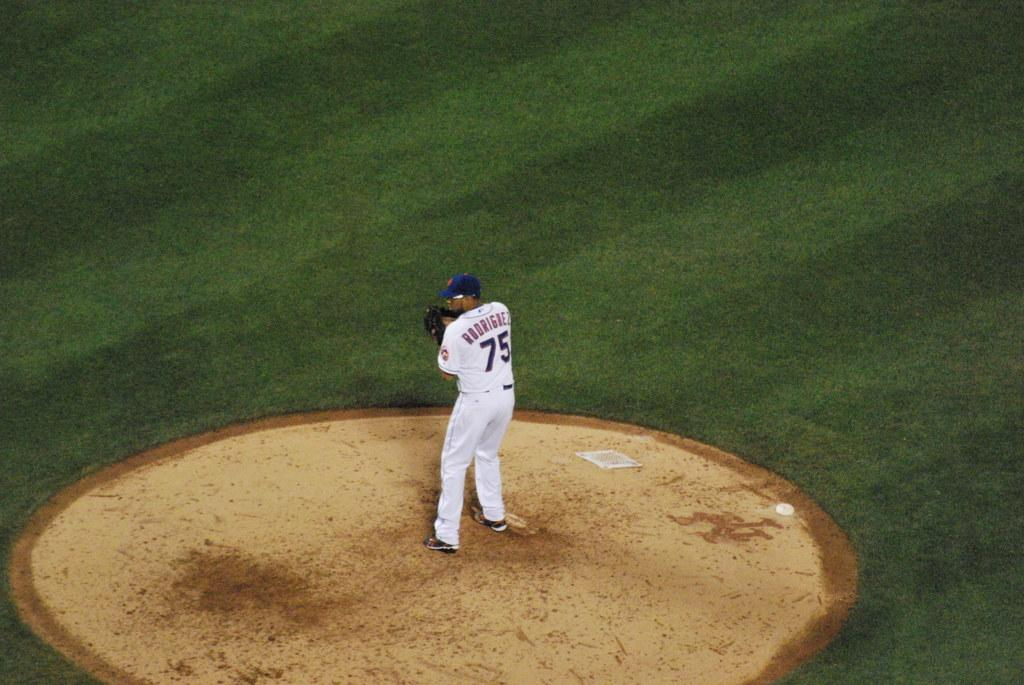Who is present in the image? There is a man in the image. What is the man doing in the image? The man is standing in the image. What accessories is the man wearing in the image? The man is wearing gloves on his hands and a cap on his head. What type of ground is visible in the image? There is grass on the ground in the image. What color is the man's dress in the image? The man is wearing a white color dress in the image. How does the man divide the grass in the image? There is no indication in the image that the man is dividing the grass, and the man's actions are not related to dividing anything. 